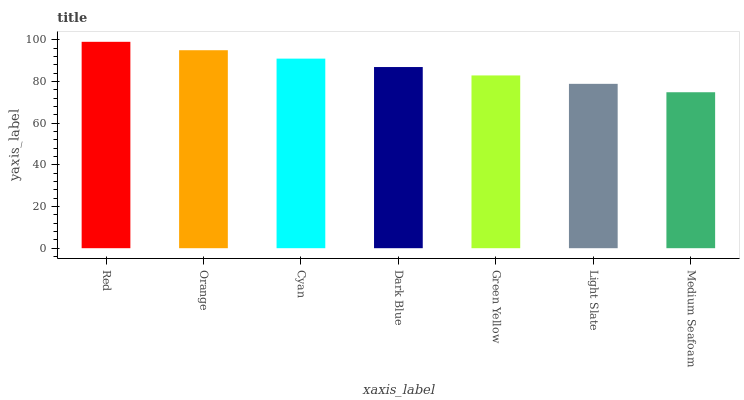Is Orange the minimum?
Answer yes or no. No. Is Orange the maximum?
Answer yes or no. No. Is Red greater than Orange?
Answer yes or no. Yes. Is Orange less than Red?
Answer yes or no. Yes. Is Orange greater than Red?
Answer yes or no. No. Is Red less than Orange?
Answer yes or no. No. Is Dark Blue the high median?
Answer yes or no. Yes. Is Dark Blue the low median?
Answer yes or no. Yes. Is Green Yellow the high median?
Answer yes or no. No. Is Cyan the low median?
Answer yes or no. No. 